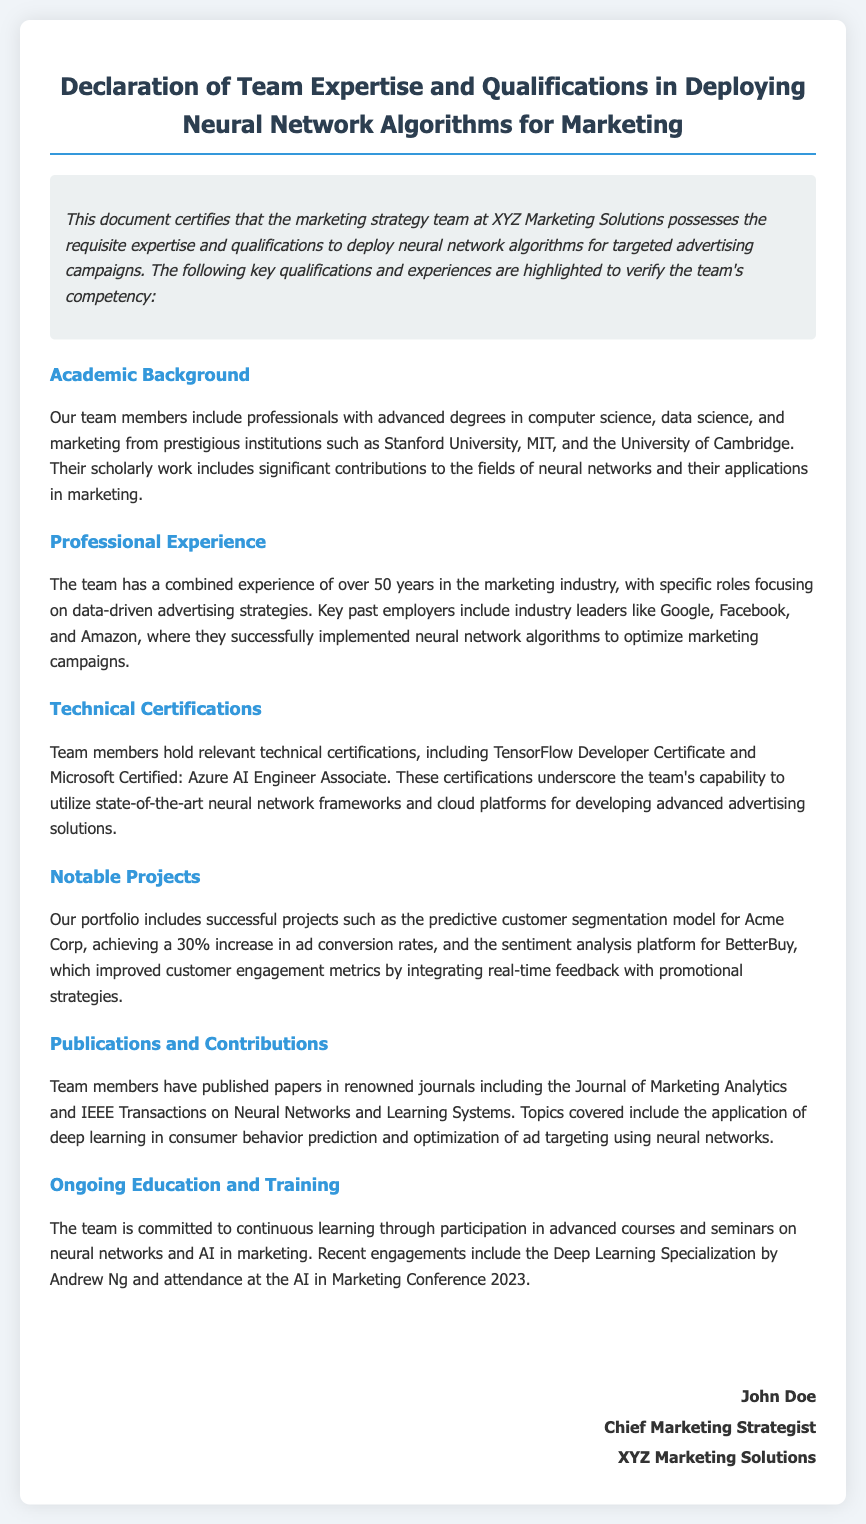What is the title of the document? The title is prominently displayed at the top of the document, indicating its purpose.
Answer: Declaration of Team Expertise and Qualifications in Deploying Neural Network Algorithms for Marketing Who is the Chief Marketing Strategist? The signature section at the end of the document identifies the person responsible for the declaration.
Answer: John Doe What certification do team members hold related to TensorFlow? The document mentions specific technical certifications held by team members.
Answer: TensorFlow Developer Certificate What notable project led to a 30% increase in ad conversion rates? The notable projects section highlights a specific successful project that achieved this result.
Answer: Predictive customer segmentation model for Acme Corp Which institutions did team members graduate from? The academic background section lists prestigious institutions for the team's academic qualifications.
Answer: Stanford University, MIT, University of Cambridge How many years of combined experience does the team have in the marketing industry? The professional experience section provides a specific number regarding the team's collective experience.
Answer: Over 50 years What commitment is mentioned regarding ongoing education? The document discusses the team's dedication to continuous learning and improving their skills.
Answer: Continuous learning In which journal have team members published papers? The publications section refers to a specific journal associated with the team's contributions.
Answer: Journal of Marketing Analytics 